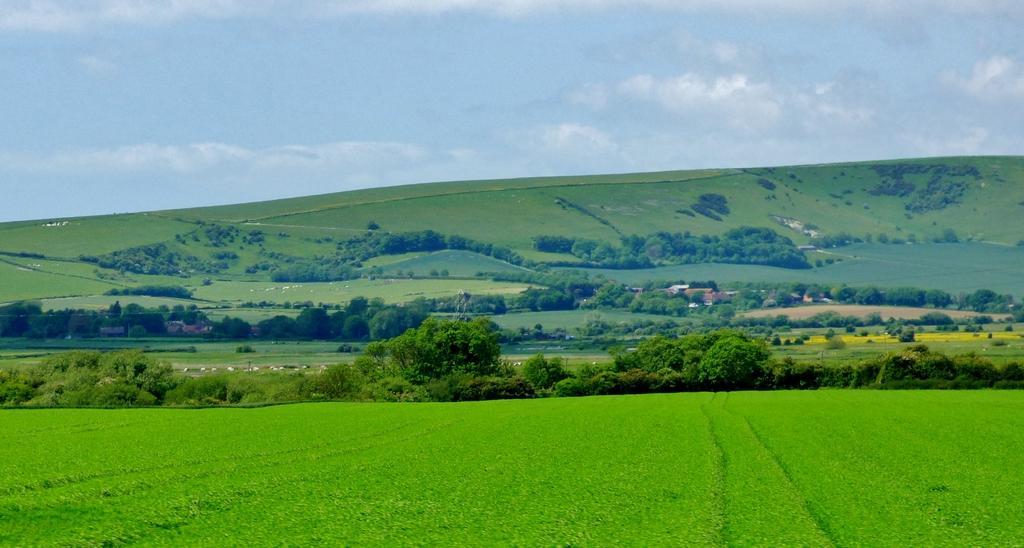Please provide a concise description of this image. In the foreground of this image, there is greenery. In the background, there are trees, few buildings and greenery on the slope surface. On the top, there is the sky and the cloud. 